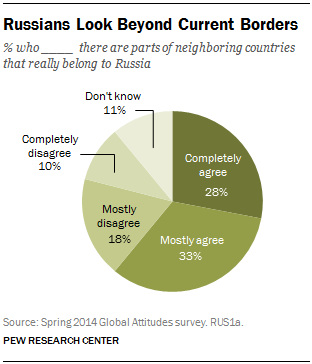Give some essential details in this illustration. Thirty-three percent represents mostly agree. 